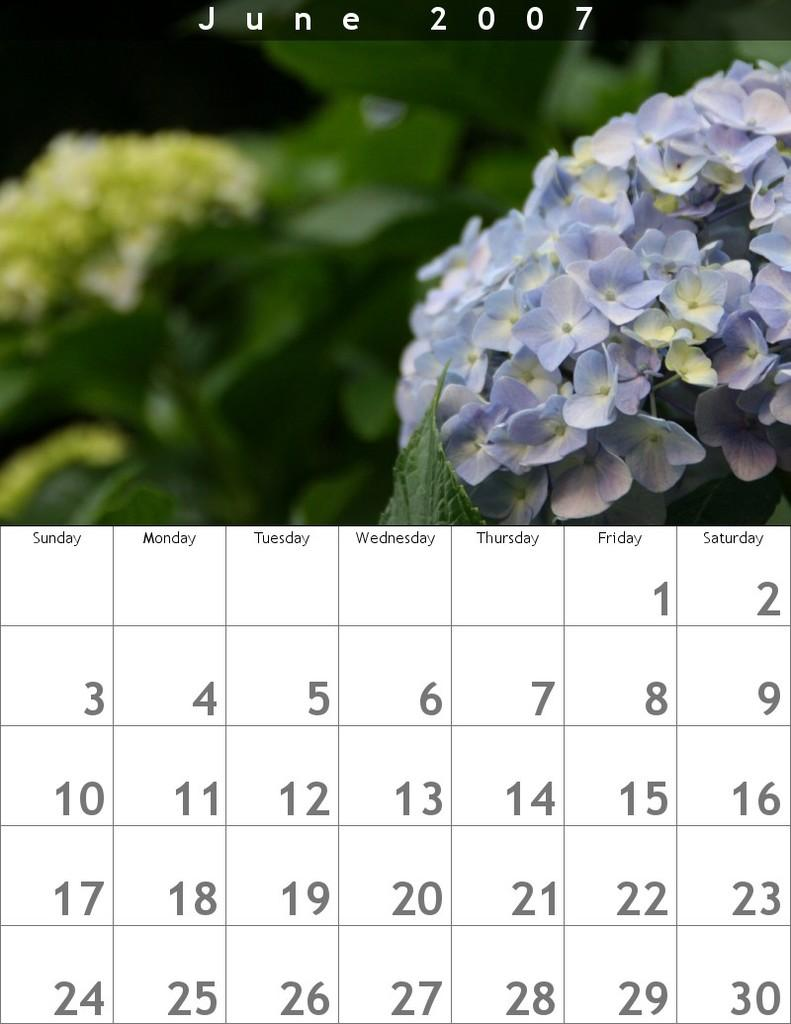What is the main object in the image? There is a calendar in the image. What other elements can be seen in the image? There are flowers and a watermark visible in the image. How would you describe the overall quality of the image? The image appears to be blurred in some areas. What type of debt is being discussed in the image? There is no mention of debt in the image; it features a calendar, flowers, and a watermark. What kind of breakfast is being served in the image? There is no breakfast present in the image; it only contains a calendar, flowers, and a watermark. 